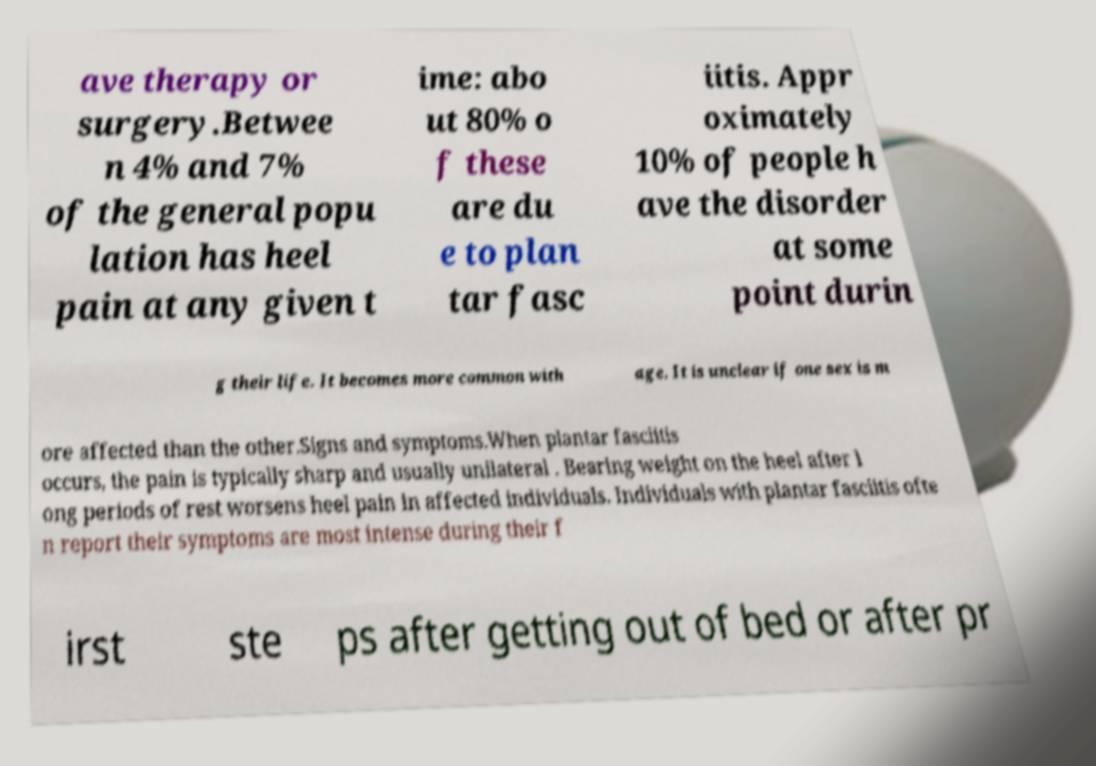For documentation purposes, I need the text within this image transcribed. Could you provide that? ave therapy or surgery.Betwee n 4% and 7% of the general popu lation has heel pain at any given t ime: abo ut 80% o f these are du e to plan tar fasc iitis. Appr oximately 10% of people h ave the disorder at some point durin g their life. It becomes more common with age. It is unclear if one sex is m ore affected than the other.Signs and symptoms.When plantar fasciitis occurs, the pain is typically sharp and usually unilateral . Bearing weight on the heel after l ong periods of rest worsens heel pain in affected individuals. Individuals with plantar fasciitis ofte n report their symptoms are most intense during their f irst ste ps after getting out of bed or after pr 